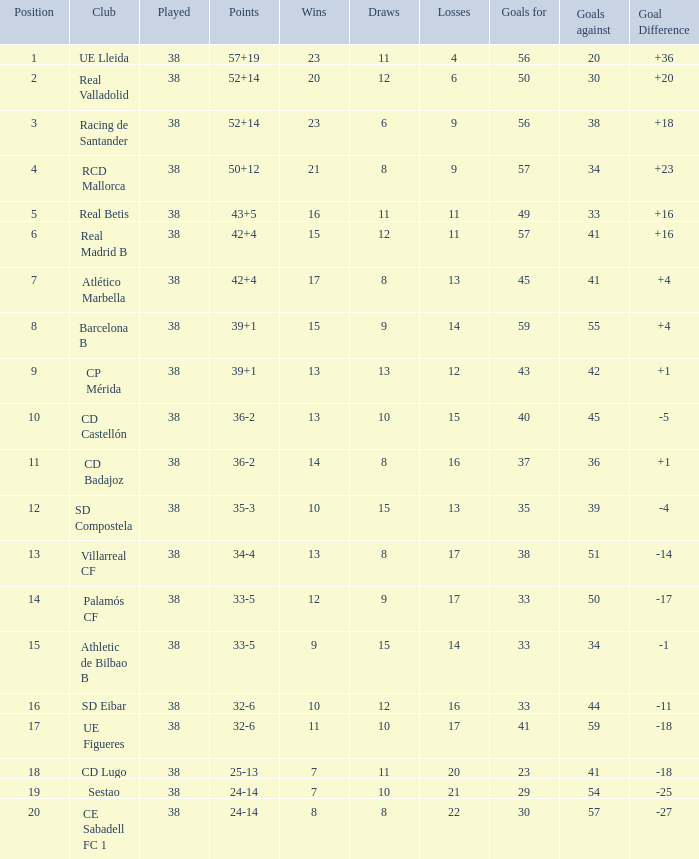Parse the full table. {'header': ['Position', 'Club', 'Played', 'Points', 'Wins', 'Draws', 'Losses', 'Goals for', 'Goals against', 'Goal Difference'], 'rows': [['1', 'UE Lleida', '38', '57+19', '23', '11', '4', '56', '20', '+36'], ['2', 'Real Valladolid', '38', '52+14', '20', '12', '6', '50', '30', '+20'], ['3', 'Racing de Santander', '38', '52+14', '23', '6', '9', '56', '38', '+18'], ['4', 'RCD Mallorca', '38', '50+12', '21', '8', '9', '57', '34', '+23'], ['5', 'Real Betis', '38', '43+5', '16', '11', '11', '49', '33', '+16'], ['6', 'Real Madrid B', '38', '42+4', '15', '12', '11', '57', '41', '+16'], ['7', 'Atlético Marbella', '38', '42+4', '17', '8', '13', '45', '41', '+4'], ['8', 'Barcelona B', '38', '39+1', '15', '9', '14', '59', '55', '+4'], ['9', 'CP Mérida', '38', '39+1', '13', '13', '12', '43', '42', '+1'], ['10', 'CD Castellón', '38', '36-2', '13', '10', '15', '40', '45', '-5'], ['11', 'CD Badajoz', '38', '36-2', '14', '8', '16', '37', '36', '+1'], ['12', 'SD Compostela', '38', '35-3', '10', '15', '13', '35', '39', '-4'], ['13', 'Villarreal CF', '38', '34-4', '13', '8', '17', '38', '51', '-14'], ['14', 'Palamós CF', '38', '33-5', '12', '9', '17', '33', '50', '-17'], ['15', 'Athletic de Bilbao B', '38', '33-5', '9', '15', '14', '33', '34', '-1'], ['16', 'SD Eibar', '38', '32-6', '10', '12', '16', '33', '44', '-11'], ['17', 'UE Figueres', '38', '32-6', '11', '10', '17', '41', '59', '-18'], ['18', 'CD Lugo', '38', '25-13', '7', '11', '20', '23', '41', '-18'], ['19', 'Sestao', '38', '24-14', '7', '10', '21', '29', '54', '-25'], ['20', 'CE Sabadell FC 1', '38', '24-14', '8', '8', '22', '30', '57', '-27']]} What is the greatest number attained when the goal difference is under -27? None. 